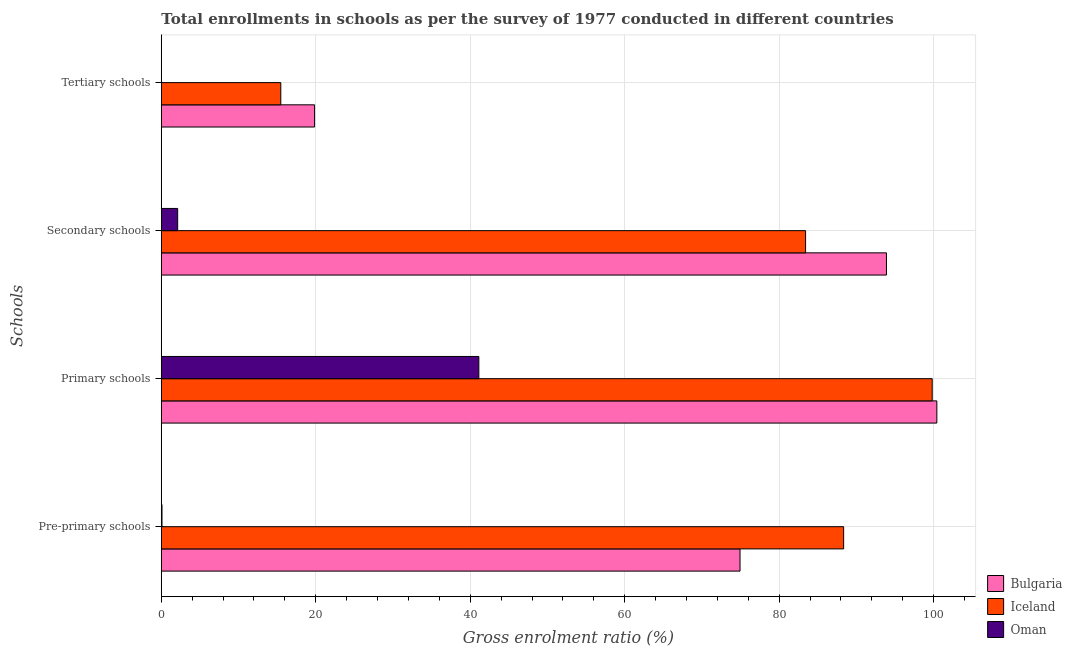How many groups of bars are there?
Your answer should be very brief. 4. Are the number of bars on each tick of the Y-axis equal?
Your response must be concise. Yes. How many bars are there on the 2nd tick from the top?
Keep it short and to the point. 3. What is the label of the 1st group of bars from the top?
Provide a short and direct response. Tertiary schools. What is the gross enrolment ratio in pre-primary schools in Oman?
Provide a succinct answer. 0.09. Across all countries, what is the maximum gross enrolment ratio in pre-primary schools?
Provide a succinct answer. 88.35. Across all countries, what is the minimum gross enrolment ratio in secondary schools?
Your answer should be compact. 2.12. In which country was the gross enrolment ratio in secondary schools minimum?
Your answer should be compact. Oman. What is the total gross enrolment ratio in secondary schools in the graph?
Ensure brevity in your answer.  179.44. What is the difference between the gross enrolment ratio in secondary schools in Iceland and that in Oman?
Your answer should be compact. 81.31. What is the difference between the gross enrolment ratio in secondary schools in Iceland and the gross enrolment ratio in tertiary schools in Oman?
Your answer should be very brief. 83.4. What is the average gross enrolment ratio in primary schools per country?
Offer a terse response. 80.45. What is the difference between the gross enrolment ratio in secondary schools and gross enrolment ratio in pre-primary schools in Bulgaria?
Provide a short and direct response. 18.96. What is the ratio of the gross enrolment ratio in tertiary schools in Bulgaria to that in Iceland?
Make the answer very short. 1.28. Is the gross enrolment ratio in tertiary schools in Bulgaria less than that in Oman?
Offer a very short reply. No. Is the difference between the gross enrolment ratio in secondary schools in Iceland and Oman greater than the difference between the gross enrolment ratio in tertiary schools in Iceland and Oman?
Offer a very short reply. Yes. What is the difference between the highest and the second highest gross enrolment ratio in secondary schools?
Ensure brevity in your answer.  10.47. What is the difference between the highest and the lowest gross enrolment ratio in secondary schools?
Keep it short and to the point. 91.78. In how many countries, is the gross enrolment ratio in primary schools greater than the average gross enrolment ratio in primary schools taken over all countries?
Your response must be concise. 2. Is it the case that in every country, the sum of the gross enrolment ratio in tertiary schools and gross enrolment ratio in primary schools is greater than the sum of gross enrolment ratio in secondary schools and gross enrolment ratio in pre-primary schools?
Provide a short and direct response. Yes. What does the 3rd bar from the top in Pre-primary schools represents?
Offer a very short reply. Bulgaria. Is it the case that in every country, the sum of the gross enrolment ratio in pre-primary schools and gross enrolment ratio in primary schools is greater than the gross enrolment ratio in secondary schools?
Your answer should be very brief. Yes. How many bars are there?
Keep it short and to the point. 12. How many countries are there in the graph?
Offer a terse response. 3. What is the difference between two consecutive major ticks on the X-axis?
Ensure brevity in your answer.  20. Are the values on the major ticks of X-axis written in scientific E-notation?
Provide a succinct answer. No. Does the graph contain any zero values?
Ensure brevity in your answer.  No. Where does the legend appear in the graph?
Ensure brevity in your answer.  Bottom right. What is the title of the graph?
Give a very brief answer. Total enrollments in schools as per the survey of 1977 conducted in different countries. Does "Fragile and conflict affected situations" appear as one of the legend labels in the graph?
Your response must be concise. No. What is the label or title of the Y-axis?
Keep it short and to the point. Schools. What is the Gross enrolment ratio (%) of Bulgaria in Pre-primary schools?
Give a very brief answer. 74.94. What is the Gross enrolment ratio (%) in Iceland in Pre-primary schools?
Ensure brevity in your answer.  88.35. What is the Gross enrolment ratio (%) in Oman in Pre-primary schools?
Ensure brevity in your answer.  0.09. What is the Gross enrolment ratio (%) of Bulgaria in Primary schools?
Your answer should be compact. 100.42. What is the Gross enrolment ratio (%) of Iceland in Primary schools?
Keep it short and to the point. 99.82. What is the Gross enrolment ratio (%) of Oman in Primary schools?
Offer a very short reply. 41.11. What is the Gross enrolment ratio (%) of Bulgaria in Secondary schools?
Provide a succinct answer. 93.9. What is the Gross enrolment ratio (%) of Iceland in Secondary schools?
Keep it short and to the point. 83.42. What is the Gross enrolment ratio (%) of Oman in Secondary schools?
Your answer should be very brief. 2.12. What is the Gross enrolment ratio (%) in Bulgaria in Tertiary schools?
Offer a terse response. 19.84. What is the Gross enrolment ratio (%) in Iceland in Tertiary schools?
Make the answer very short. 15.47. What is the Gross enrolment ratio (%) of Oman in Tertiary schools?
Provide a short and direct response. 0.02. Across all Schools, what is the maximum Gross enrolment ratio (%) of Bulgaria?
Your answer should be compact. 100.42. Across all Schools, what is the maximum Gross enrolment ratio (%) in Iceland?
Give a very brief answer. 99.82. Across all Schools, what is the maximum Gross enrolment ratio (%) of Oman?
Your answer should be compact. 41.11. Across all Schools, what is the minimum Gross enrolment ratio (%) of Bulgaria?
Offer a very short reply. 19.84. Across all Schools, what is the minimum Gross enrolment ratio (%) in Iceland?
Keep it short and to the point. 15.47. Across all Schools, what is the minimum Gross enrolment ratio (%) of Oman?
Provide a succinct answer. 0.02. What is the total Gross enrolment ratio (%) in Bulgaria in the graph?
Provide a short and direct response. 289.1. What is the total Gross enrolment ratio (%) of Iceland in the graph?
Your response must be concise. 287.07. What is the total Gross enrolment ratio (%) of Oman in the graph?
Your answer should be very brief. 43.34. What is the difference between the Gross enrolment ratio (%) of Bulgaria in Pre-primary schools and that in Primary schools?
Keep it short and to the point. -25.48. What is the difference between the Gross enrolment ratio (%) in Iceland in Pre-primary schools and that in Primary schools?
Provide a succinct answer. -11.47. What is the difference between the Gross enrolment ratio (%) of Oman in Pre-primary schools and that in Primary schools?
Make the answer very short. -41.03. What is the difference between the Gross enrolment ratio (%) of Bulgaria in Pre-primary schools and that in Secondary schools?
Provide a succinct answer. -18.96. What is the difference between the Gross enrolment ratio (%) of Iceland in Pre-primary schools and that in Secondary schools?
Offer a very short reply. 4.93. What is the difference between the Gross enrolment ratio (%) of Oman in Pre-primary schools and that in Secondary schools?
Your response must be concise. -2.03. What is the difference between the Gross enrolment ratio (%) of Bulgaria in Pre-primary schools and that in Tertiary schools?
Your answer should be very brief. 55.09. What is the difference between the Gross enrolment ratio (%) of Iceland in Pre-primary schools and that in Tertiary schools?
Provide a succinct answer. 72.88. What is the difference between the Gross enrolment ratio (%) in Oman in Pre-primary schools and that in Tertiary schools?
Offer a very short reply. 0.07. What is the difference between the Gross enrolment ratio (%) in Bulgaria in Primary schools and that in Secondary schools?
Ensure brevity in your answer.  6.52. What is the difference between the Gross enrolment ratio (%) of Iceland in Primary schools and that in Secondary schools?
Your response must be concise. 16.4. What is the difference between the Gross enrolment ratio (%) of Oman in Primary schools and that in Secondary schools?
Make the answer very short. 39. What is the difference between the Gross enrolment ratio (%) in Bulgaria in Primary schools and that in Tertiary schools?
Offer a terse response. 80.58. What is the difference between the Gross enrolment ratio (%) in Iceland in Primary schools and that in Tertiary schools?
Ensure brevity in your answer.  84.35. What is the difference between the Gross enrolment ratio (%) of Oman in Primary schools and that in Tertiary schools?
Offer a very short reply. 41.09. What is the difference between the Gross enrolment ratio (%) of Bulgaria in Secondary schools and that in Tertiary schools?
Offer a terse response. 74.05. What is the difference between the Gross enrolment ratio (%) in Iceland in Secondary schools and that in Tertiary schools?
Provide a succinct answer. 67.95. What is the difference between the Gross enrolment ratio (%) of Oman in Secondary schools and that in Tertiary schools?
Keep it short and to the point. 2.09. What is the difference between the Gross enrolment ratio (%) of Bulgaria in Pre-primary schools and the Gross enrolment ratio (%) of Iceland in Primary schools?
Give a very brief answer. -24.88. What is the difference between the Gross enrolment ratio (%) of Bulgaria in Pre-primary schools and the Gross enrolment ratio (%) of Oman in Primary schools?
Provide a short and direct response. 33.82. What is the difference between the Gross enrolment ratio (%) in Iceland in Pre-primary schools and the Gross enrolment ratio (%) in Oman in Primary schools?
Give a very brief answer. 47.24. What is the difference between the Gross enrolment ratio (%) of Bulgaria in Pre-primary schools and the Gross enrolment ratio (%) of Iceland in Secondary schools?
Provide a succinct answer. -8.49. What is the difference between the Gross enrolment ratio (%) in Bulgaria in Pre-primary schools and the Gross enrolment ratio (%) in Oman in Secondary schools?
Provide a succinct answer. 72.82. What is the difference between the Gross enrolment ratio (%) of Iceland in Pre-primary schools and the Gross enrolment ratio (%) of Oman in Secondary schools?
Your response must be concise. 86.23. What is the difference between the Gross enrolment ratio (%) in Bulgaria in Pre-primary schools and the Gross enrolment ratio (%) in Iceland in Tertiary schools?
Provide a short and direct response. 59.46. What is the difference between the Gross enrolment ratio (%) of Bulgaria in Pre-primary schools and the Gross enrolment ratio (%) of Oman in Tertiary schools?
Your answer should be very brief. 74.91. What is the difference between the Gross enrolment ratio (%) in Iceland in Pre-primary schools and the Gross enrolment ratio (%) in Oman in Tertiary schools?
Offer a terse response. 88.33. What is the difference between the Gross enrolment ratio (%) of Bulgaria in Primary schools and the Gross enrolment ratio (%) of Iceland in Secondary schools?
Make the answer very short. 17. What is the difference between the Gross enrolment ratio (%) in Bulgaria in Primary schools and the Gross enrolment ratio (%) in Oman in Secondary schools?
Ensure brevity in your answer.  98.3. What is the difference between the Gross enrolment ratio (%) of Iceland in Primary schools and the Gross enrolment ratio (%) of Oman in Secondary schools?
Provide a succinct answer. 97.7. What is the difference between the Gross enrolment ratio (%) in Bulgaria in Primary schools and the Gross enrolment ratio (%) in Iceland in Tertiary schools?
Your answer should be compact. 84.95. What is the difference between the Gross enrolment ratio (%) in Bulgaria in Primary schools and the Gross enrolment ratio (%) in Oman in Tertiary schools?
Make the answer very short. 100.4. What is the difference between the Gross enrolment ratio (%) of Iceland in Primary schools and the Gross enrolment ratio (%) of Oman in Tertiary schools?
Ensure brevity in your answer.  99.8. What is the difference between the Gross enrolment ratio (%) in Bulgaria in Secondary schools and the Gross enrolment ratio (%) in Iceland in Tertiary schools?
Provide a succinct answer. 78.43. What is the difference between the Gross enrolment ratio (%) in Bulgaria in Secondary schools and the Gross enrolment ratio (%) in Oman in Tertiary schools?
Keep it short and to the point. 93.87. What is the difference between the Gross enrolment ratio (%) in Iceland in Secondary schools and the Gross enrolment ratio (%) in Oman in Tertiary schools?
Provide a succinct answer. 83.4. What is the average Gross enrolment ratio (%) of Bulgaria per Schools?
Provide a short and direct response. 72.27. What is the average Gross enrolment ratio (%) of Iceland per Schools?
Keep it short and to the point. 71.77. What is the average Gross enrolment ratio (%) of Oman per Schools?
Provide a succinct answer. 10.84. What is the difference between the Gross enrolment ratio (%) of Bulgaria and Gross enrolment ratio (%) of Iceland in Pre-primary schools?
Ensure brevity in your answer.  -13.42. What is the difference between the Gross enrolment ratio (%) in Bulgaria and Gross enrolment ratio (%) in Oman in Pre-primary schools?
Give a very brief answer. 74.85. What is the difference between the Gross enrolment ratio (%) of Iceland and Gross enrolment ratio (%) of Oman in Pre-primary schools?
Offer a terse response. 88.26. What is the difference between the Gross enrolment ratio (%) of Bulgaria and Gross enrolment ratio (%) of Iceland in Primary schools?
Give a very brief answer. 0.6. What is the difference between the Gross enrolment ratio (%) of Bulgaria and Gross enrolment ratio (%) of Oman in Primary schools?
Provide a short and direct response. 59.3. What is the difference between the Gross enrolment ratio (%) in Iceland and Gross enrolment ratio (%) in Oman in Primary schools?
Make the answer very short. 58.7. What is the difference between the Gross enrolment ratio (%) in Bulgaria and Gross enrolment ratio (%) in Iceland in Secondary schools?
Make the answer very short. 10.47. What is the difference between the Gross enrolment ratio (%) in Bulgaria and Gross enrolment ratio (%) in Oman in Secondary schools?
Your answer should be compact. 91.78. What is the difference between the Gross enrolment ratio (%) in Iceland and Gross enrolment ratio (%) in Oman in Secondary schools?
Offer a very short reply. 81.31. What is the difference between the Gross enrolment ratio (%) in Bulgaria and Gross enrolment ratio (%) in Iceland in Tertiary schools?
Give a very brief answer. 4.37. What is the difference between the Gross enrolment ratio (%) of Bulgaria and Gross enrolment ratio (%) of Oman in Tertiary schools?
Your answer should be compact. 19.82. What is the difference between the Gross enrolment ratio (%) of Iceland and Gross enrolment ratio (%) of Oman in Tertiary schools?
Make the answer very short. 15.45. What is the ratio of the Gross enrolment ratio (%) of Bulgaria in Pre-primary schools to that in Primary schools?
Keep it short and to the point. 0.75. What is the ratio of the Gross enrolment ratio (%) of Iceland in Pre-primary schools to that in Primary schools?
Keep it short and to the point. 0.89. What is the ratio of the Gross enrolment ratio (%) of Oman in Pre-primary schools to that in Primary schools?
Give a very brief answer. 0. What is the ratio of the Gross enrolment ratio (%) of Bulgaria in Pre-primary schools to that in Secondary schools?
Ensure brevity in your answer.  0.8. What is the ratio of the Gross enrolment ratio (%) in Iceland in Pre-primary schools to that in Secondary schools?
Your answer should be very brief. 1.06. What is the ratio of the Gross enrolment ratio (%) in Oman in Pre-primary schools to that in Secondary schools?
Provide a succinct answer. 0.04. What is the ratio of the Gross enrolment ratio (%) in Bulgaria in Pre-primary schools to that in Tertiary schools?
Provide a short and direct response. 3.78. What is the ratio of the Gross enrolment ratio (%) of Iceland in Pre-primary schools to that in Tertiary schools?
Keep it short and to the point. 5.71. What is the ratio of the Gross enrolment ratio (%) of Oman in Pre-primary schools to that in Tertiary schools?
Offer a very short reply. 3.73. What is the ratio of the Gross enrolment ratio (%) in Bulgaria in Primary schools to that in Secondary schools?
Your answer should be very brief. 1.07. What is the ratio of the Gross enrolment ratio (%) of Iceland in Primary schools to that in Secondary schools?
Keep it short and to the point. 1.2. What is the ratio of the Gross enrolment ratio (%) of Oman in Primary schools to that in Secondary schools?
Provide a short and direct response. 19.42. What is the ratio of the Gross enrolment ratio (%) of Bulgaria in Primary schools to that in Tertiary schools?
Offer a very short reply. 5.06. What is the ratio of the Gross enrolment ratio (%) in Iceland in Primary schools to that in Tertiary schools?
Keep it short and to the point. 6.45. What is the ratio of the Gross enrolment ratio (%) of Oman in Primary schools to that in Tertiary schools?
Your response must be concise. 1722.44. What is the ratio of the Gross enrolment ratio (%) of Bulgaria in Secondary schools to that in Tertiary schools?
Provide a succinct answer. 4.73. What is the ratio of the Gross enrolment ratio (%) of Iceland in Secondary schools to that in Tertiary schools?
Ensure brevity in your answer.  5.39. What is the ratio of the Gross enrolment ratio (%) in Oman in Secondary schools to that in Tertiary schools?
Keep it short and to the point. 88.71. What is the difference between the highest and the second highest Gross enrolment ratio (%) of Bulgaria?
Your answer should be compact. 6.52. What is the difference between the highest and the second highest Gross enrolment ratio (%) in Iceland?
Make the answer very short. 11.47. What is the difference between the highest and the second highest Gross enrolment ratio (%) of Oman?
Make the answer very short. 39. What is the difference between the highest and the lowest Gross enrolment ratio (%) in Bulgaria?
Your response must be concise. 80.58. What is the difference between the highest and the lowest Gross enrolment ratio (%) in Iceland?
Your response must be concise. 84.35. What is the difference between the highest and the lowest Gross enrolment ratio (%) in Oman?
Offer a terse response. 41.09. 